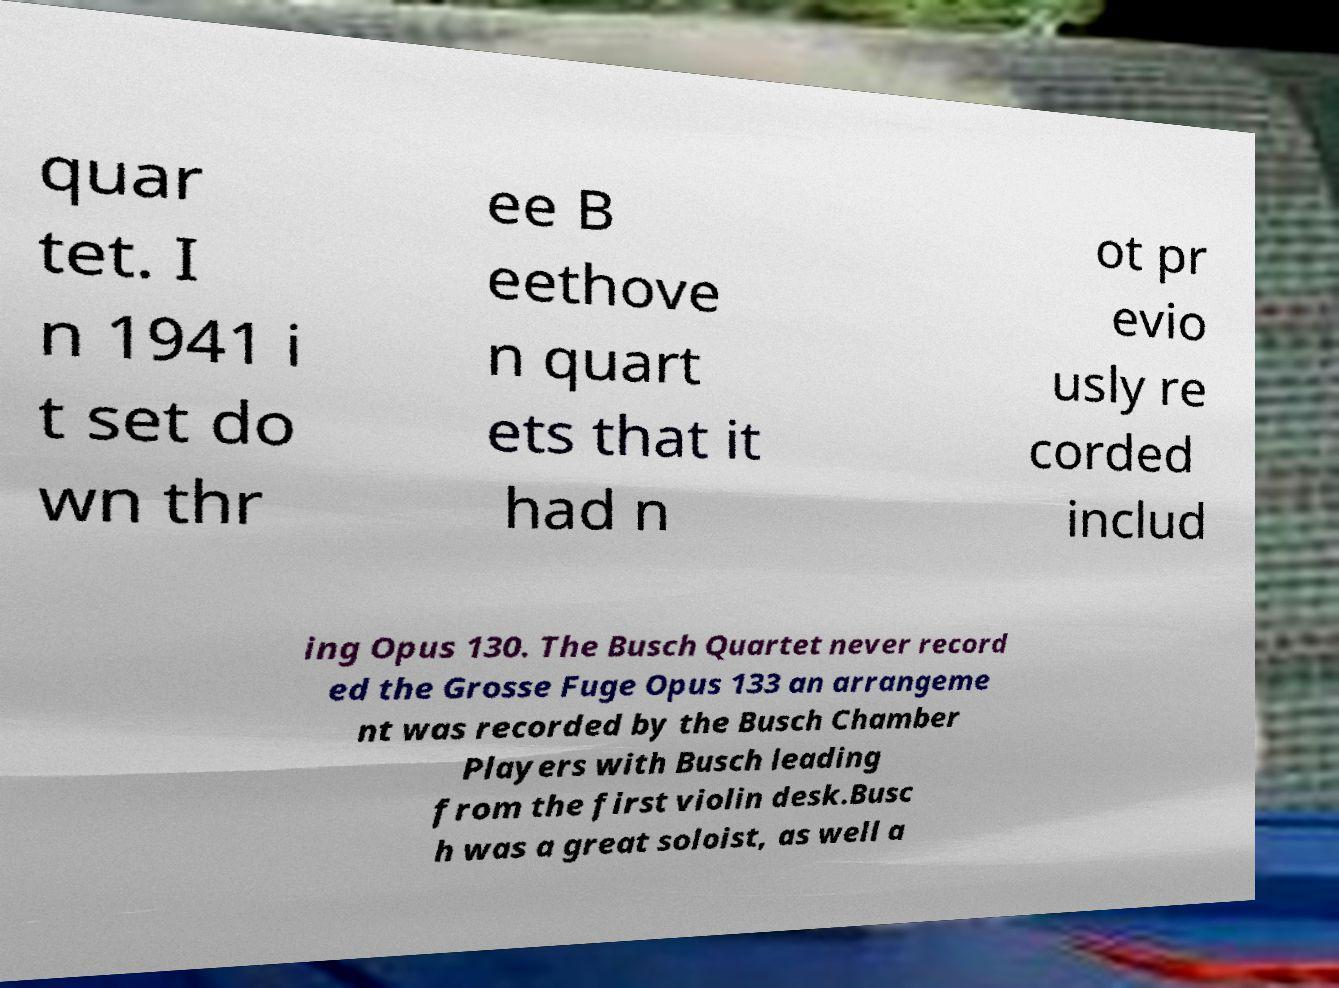Please identify and transcribe the text found in this image. quar tet. I n 1941 i t set do wn thr ee B eethove n quart ets that it had n ot pr evio usly re corded includ ing Opus 130. The Busch Quartet never record ed the Grosse Fuge Opus 133 an arrangeme nt was recorded by the Busch Chamber Players with Busch leading from the first violin desk.Busc h was a great soloist, as well a 